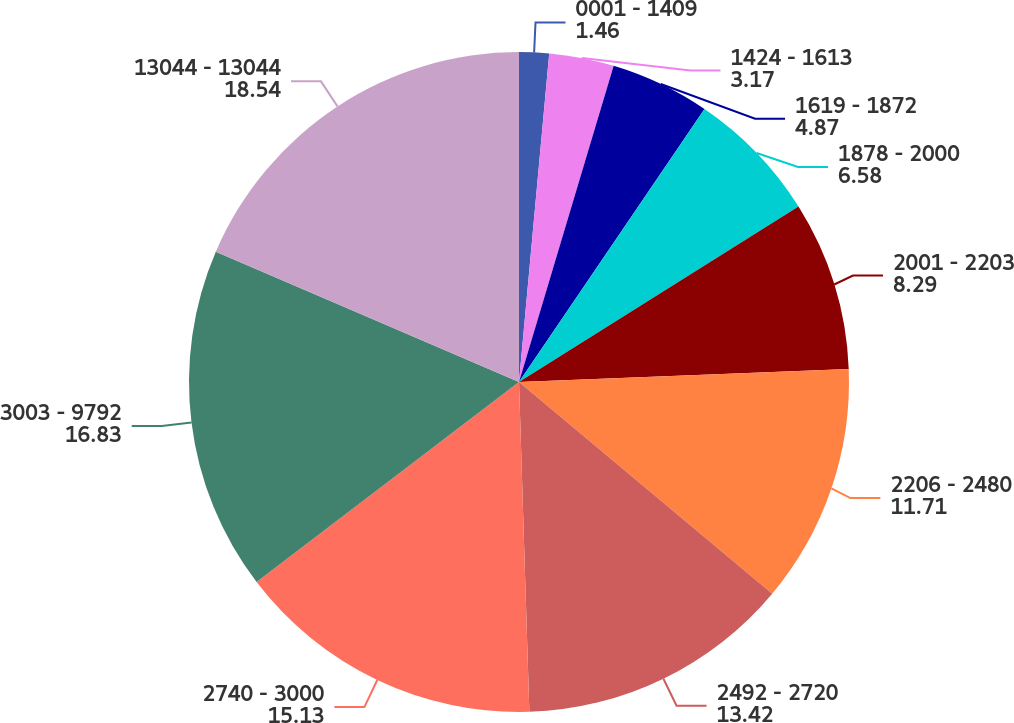Convert chart. <chart><loc_0><loc_0><loc_500><loc_500><pie_chart><fcel>0001 - 1409<fcel>1424 - 1613<fcel>1619 - 1872<fcel>1878 - 2000<fcel>2001 - 2203<fcel>2206 - 2480<fcel>2492 - 2720<fcel>2740 - 3000<fcel>3003 - 9792<fcel>13044 - 13044<nl><fcel>1.46%<fcel>3.17%<fcel>4.87%<fcel>6.58%<fcel>8.29%<fcel>11.71%<fcel>13.42%<fcel>15.13%<fcel>16.83%<fcel>18.54%<nl></chart> 